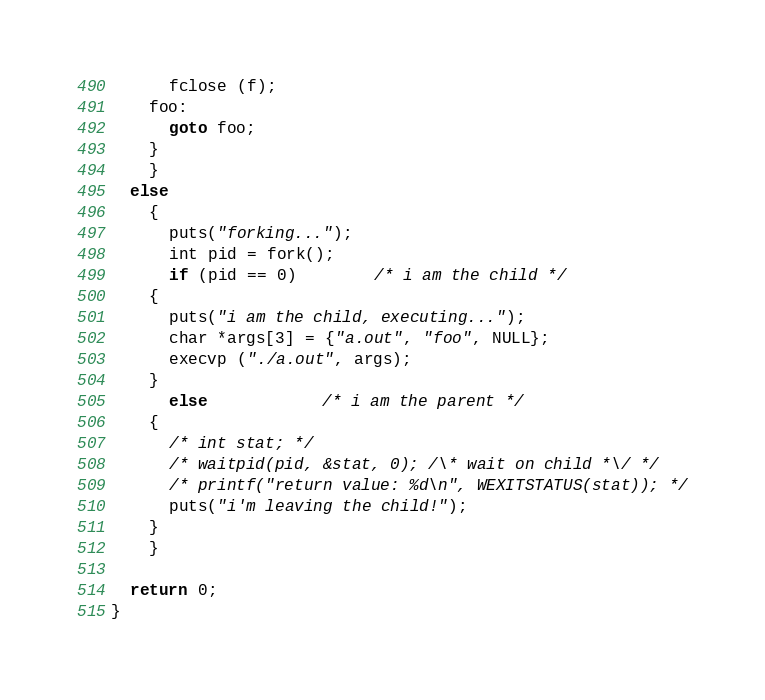Convert code to text. <code><loc_0><loc_0><loc_500><loc_500><_C_>	  fclose (f);
	foo:
	  goto foo;
	}
    }
  else
    {
      puts("forking...");
      int pid = fork();
      if (pid == 0)		/* i am the child */
	{
	  puts("i am the child, executing...");
	  char *args[3] = {"a.out", "foo", NULL};
	  execvp ("./a.out", args);
	}
      else			/* i am the parent */
	{
	  /* int stat; */
	  /* waitpid(pid, &stat, 0); /\* wait on child *\/ */
	  /* printf("return value: %d\n", WEXITSTATUS(stat)); */
	  puts("i'm leaving the child!");
	}
    }

  return 0;
}
</code> 